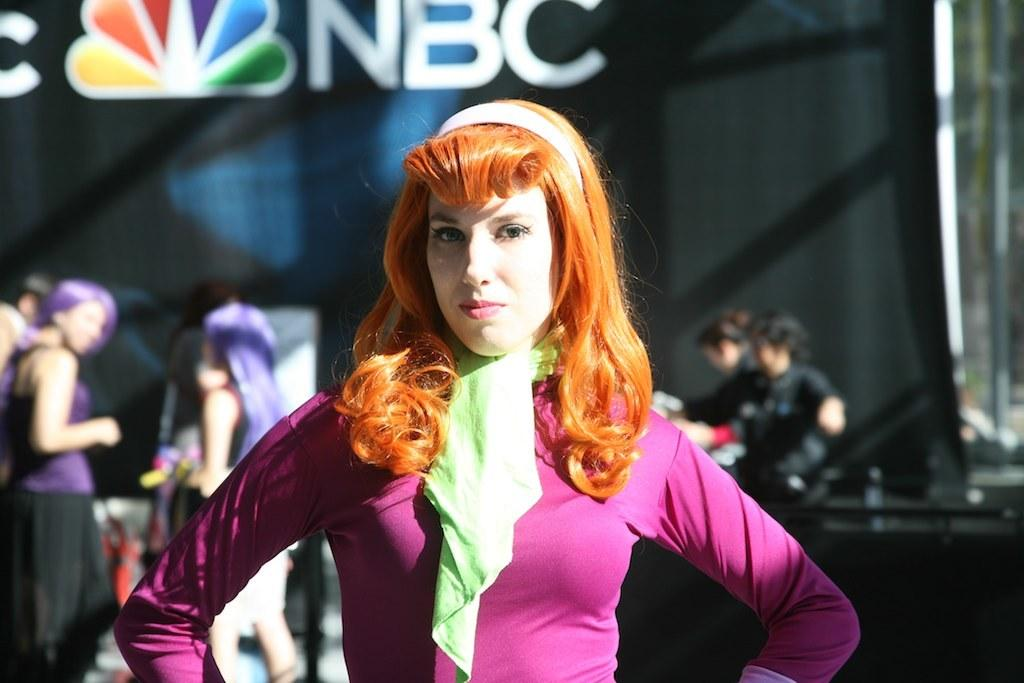What is the main subject of the image? There is a woman standing in the center of the image. How is the woman dressed in the image? The woman is wearing a different costume. What can be seen in the background of the image? There are people and other objects in the background of the image. What type of boot is the fireman wearing in the image? There is no fireman or boot present in the image. What kind of wood can be seen in the image? There is no wood visible in the image. 